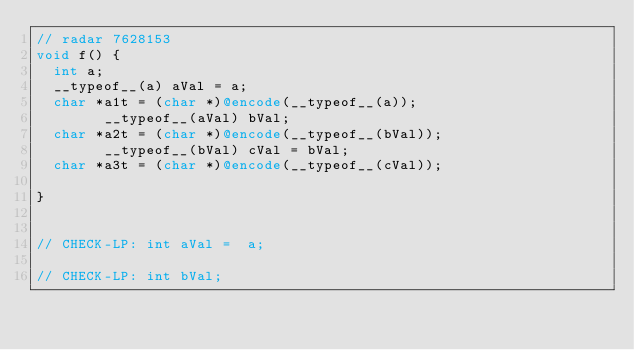Convert code to text. <code><loc_0><loc_0><loc_500><loc_500><_ObjectiveC_>// radar 7628153
void f() {
	int a;	
	__typeof__(a) aVal = a;
	char *a1t = (char *)@encode(__typeof__(a));
        __typeof__(aVal) bVal;
	char *a2t = (char *)@encode(__typeof__(bVal));
        __typeof__(bVal) cVal = bVal;
	char *a3t = (char *)@encode(__typeof__(cVal));

}


// CHECK-LP: int aVal =  a;

// CHECK-LP: int bVal;
</code> 